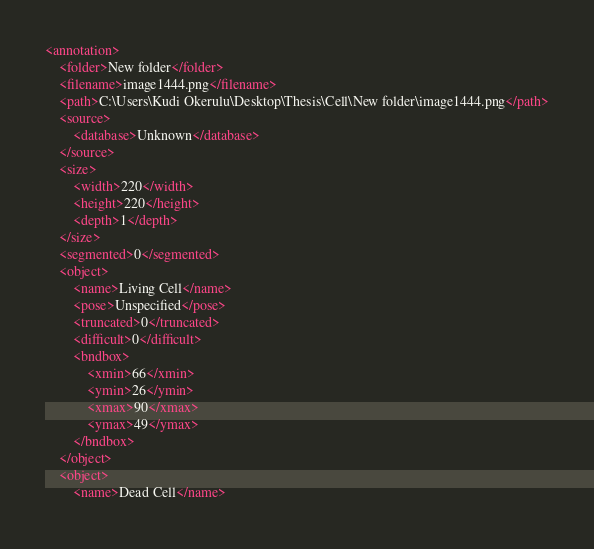<code> <loc_0><loc_0><loc_500><loc_500><_XML_><annotation>
	<folder>New folder</folder>
	<filename>image1444.png</filename>
	<path>C:\Users\Kudi Okerulu\Desktop\Thesis\Cell\New folder\image1444.png</path>
	<source>
		<database>Unknown</database>
	</source>
	<size>
		<width>220</width>
		<height>220</height>
		<depth>1</depth>
	</size>
	<segmented>0</segmented>
	<object>
		<name>Living Cell</name>
		<pose>Unspecified</pose>
		<truncated>0</truncated>
		<difficult>0</difficult>
		<bndbox>
			<xmin>66</xmin>
			<ymin>26</ymin>
			<xmax>90</xmax>
			<ymax>49</ymax>
		</bndbox>
	</object>
	<object>
		<name>Dead Cell</name></code> 